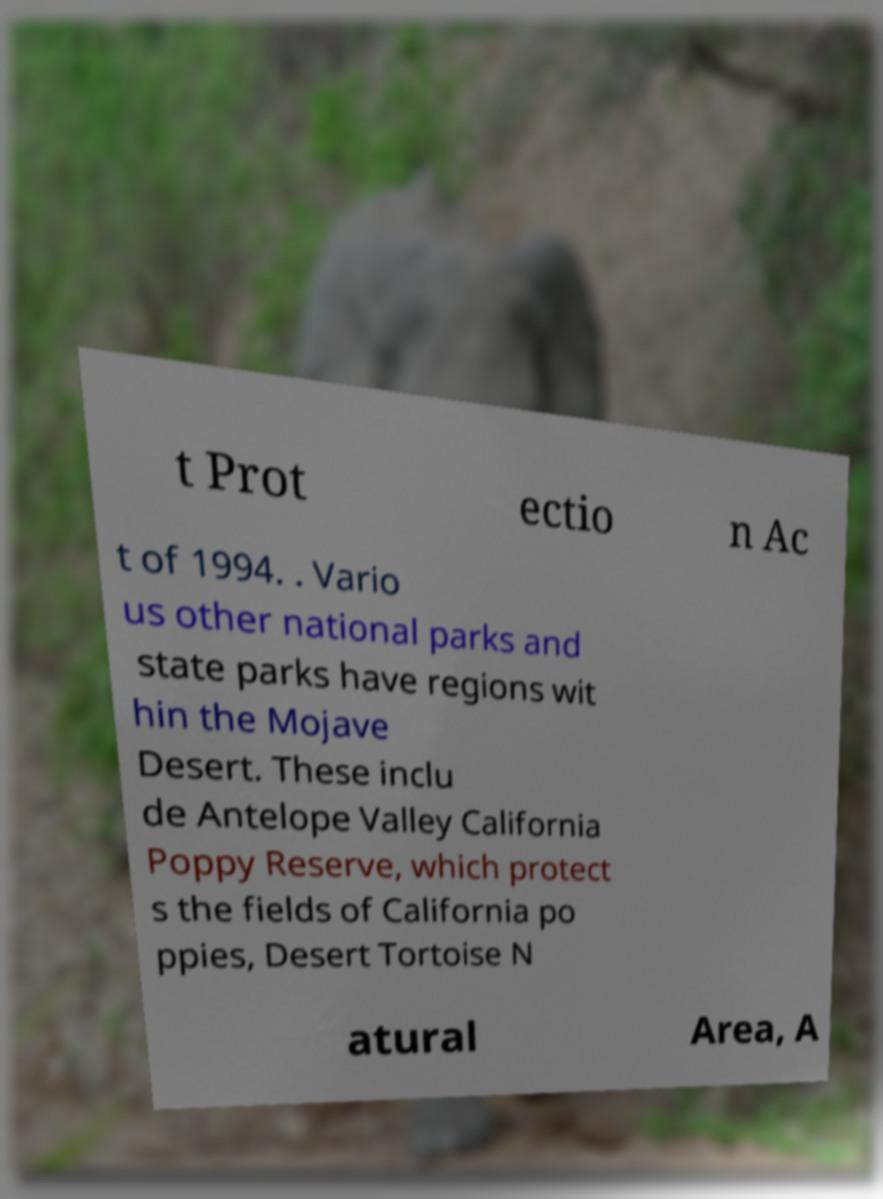There's text embedded in this image that I need extracted. Can you transcribe it verbatim? t Prot ectio n Ac t of 1994. . Vario us other national parks and state parks have regions wit hin the Mojave Desert. These inclu de Antelope Valley California Poppy Reserve, which protect s the fields of California po ppies, Desert Tortoise N atural Area, A 